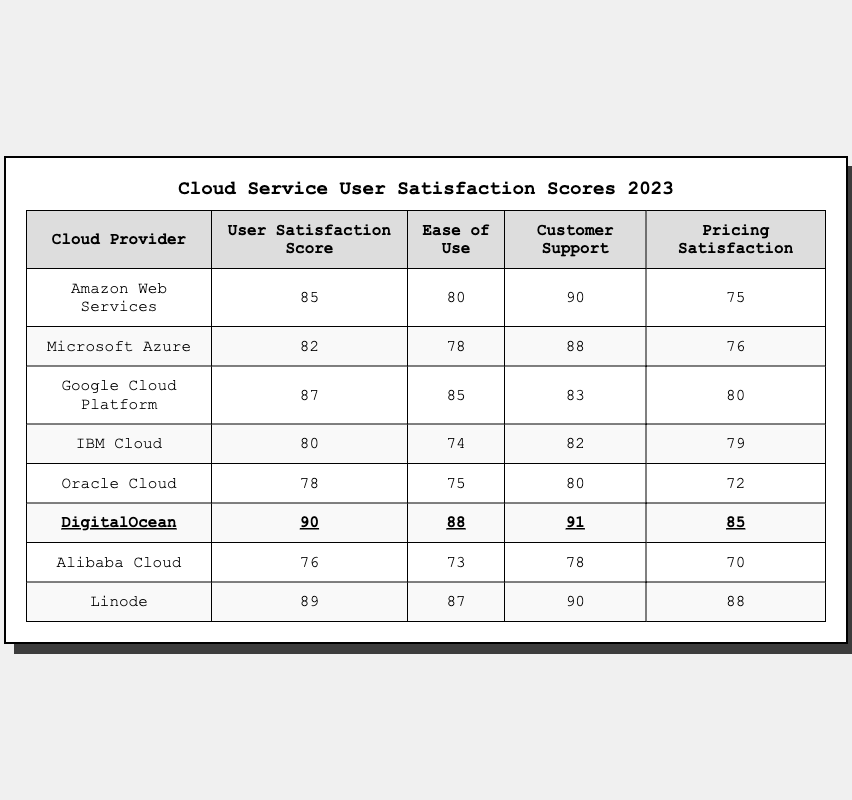What is the User Satisfaction Score for DigitalOcean? The User Satisfaction Score for DigitalOcean is stated directly in the table under the "User Satisfaction Score" column. It shows a score of 90.
Answer: 90 Which cloud provider has the highest Customer Support score? By reviewing the "Customer Support" scores in the table, DigitalOcean has the highest score of 91.
Answer: DigitalOcean What is the average Ease of Use score across all providers? To calculate the average, sum all Ease of Use scores: 80 + 78 + 85 + 74 + 75 + 88 + 73 + 87 = 640. Divide 640 by the number of providers (8) to get an average of 80.
Answer: 80 Does Amazon Web Services have the highest User Satisfaction Score? Comparing the User Satisfaction Scores in the table, the highest score belongs to DigitalOcean with 90, so AWS does not have the highest score.
Answer: No Which cloud provider has the lowest Pricing Satisfaction? Looking at the "Pricing Satisfaction" column, Alibaba Cloud has the lowest score of 70.
Answer: Alibaba Cloud What is the difference between the User Satisfaction Scores of Google Cloud Platform and IBM Cloud? The score for Google Cloud Platform is 87 and for IBM Cloud is 80. Subtract IBM's score from Google's to find the difference: 87 - 80 = 7.
Answer: 7 How many cloud providers have a User Satisfaction Score above 85? Listing the User Satisfaction Scores: DigitalOcean (90), Linode (89), Google Cloud Platform (87), and AWS (85) gives a total of four providers above 85.
Answer: 4 Is the Ease of Use score for Microsoft Azure higher than that for Oracle Cloud? The Ease of Use score for Microsoft Azure is 78, while Oracle Cloud's score is 75. Since 78 is greater than 75, the assertion is true.
Answer: Yes What is the highest score in the Pricing Satisfaction category? The table lists scores in the Pricing Satisfaction column, with DigitalOcean having the highest score of 85.
Answer: 85 Find the average Customer Support score for cloud providers with a User Satisfaction Score below 80. The providers with scores below 80 are IBM Cloud (82), and Oracle Cloud (78). The Customer Support scores are 82 and 80, respectively. Their average is (82 + 80) / 2 = 81.
Answer: 81 